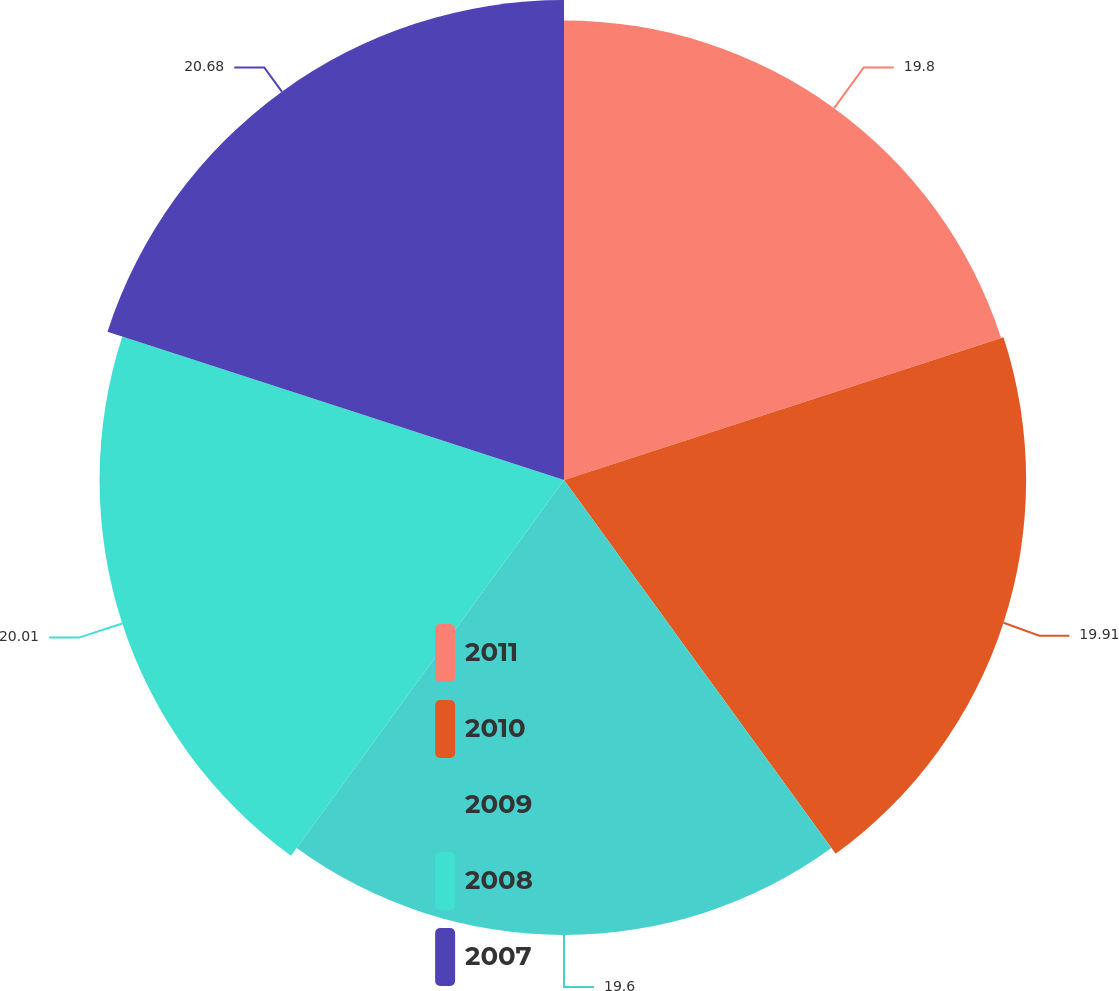Convert chart. <chart><loc_0><loc_0><loc_500><loc_500><pie_chart><fcel>2011<fcel>2010<fcel>2009<fcel>2008<fcel>2007<nl><fcel>19.8%<fcel>19.91%<fcel>19.6%<fcel>20.01%<fcel>20.68%<nl></chart> 